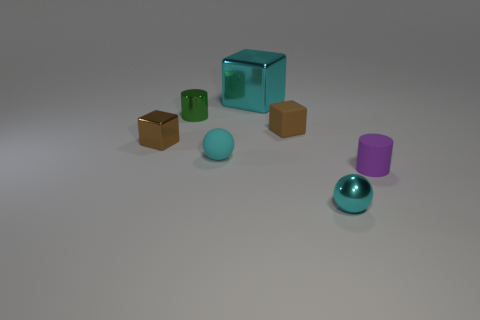Subtract all brown blocks. How many blocks are left? 1 Subtract all gray cylinders. How many brown blocks are left? 2 Add 1 large cyan things. How many objects exist? 8 Subtract all cubes. How many objects are left? 4 Subtract all small cylinders. Subtract all tiny cyan metal balls. How many objects are left? 4 Add 2 tiny cylinders. How many tiny cylinders are left? 4 Add 3 tiny green metallic things. How many tiny green metallic things exist? 4 Subtract 0 blue cubes. How many objects are left? 7 Subtract all brown balls. Subtract all green blocks. How many balls are left? 2 